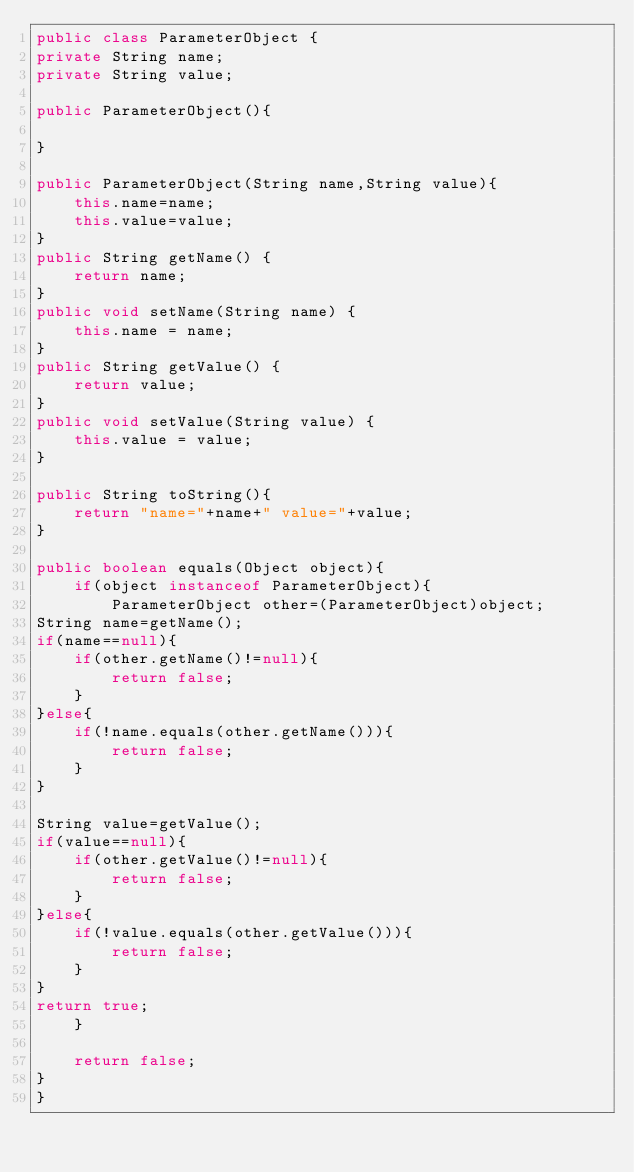Convert code to text. <code><loc_0><loc_0><loc_500><loc_500><_Java_>public class ParameterObject {
private String name;
private String value;

public ParameterObject(){
    
}

public ParameterObject(String name,String value){
    this.name=name;
    this.value=value;
}
public String getName() {
    return name;
}
public void setName(String name) {
    this.name = name;
}
public String getValue() {
    return value;
}
public void setValue(String value) {
    this.value = value;
}

public String toString(){
    return "name="+name+" value="+value;
}

public boolean equals(Object object){
    if(object instanceof ParameterObject){
        ParameterObject other=(ParameterObject)object;
String name=getName();
if(name==null){
    if(other.getName()!=null){
        return false;
    }
}else{
    if(!name.equals(other.getName())){
        return false;
    }
}

String value=getValue();
if(value==null){
    if(other.getValue()!=null){
        return false;
    }
}else{
    if(!value.equals(other.getValue())){
        return false;
    }
}
return true;
    }
    
    return false;
}
}
</code> 